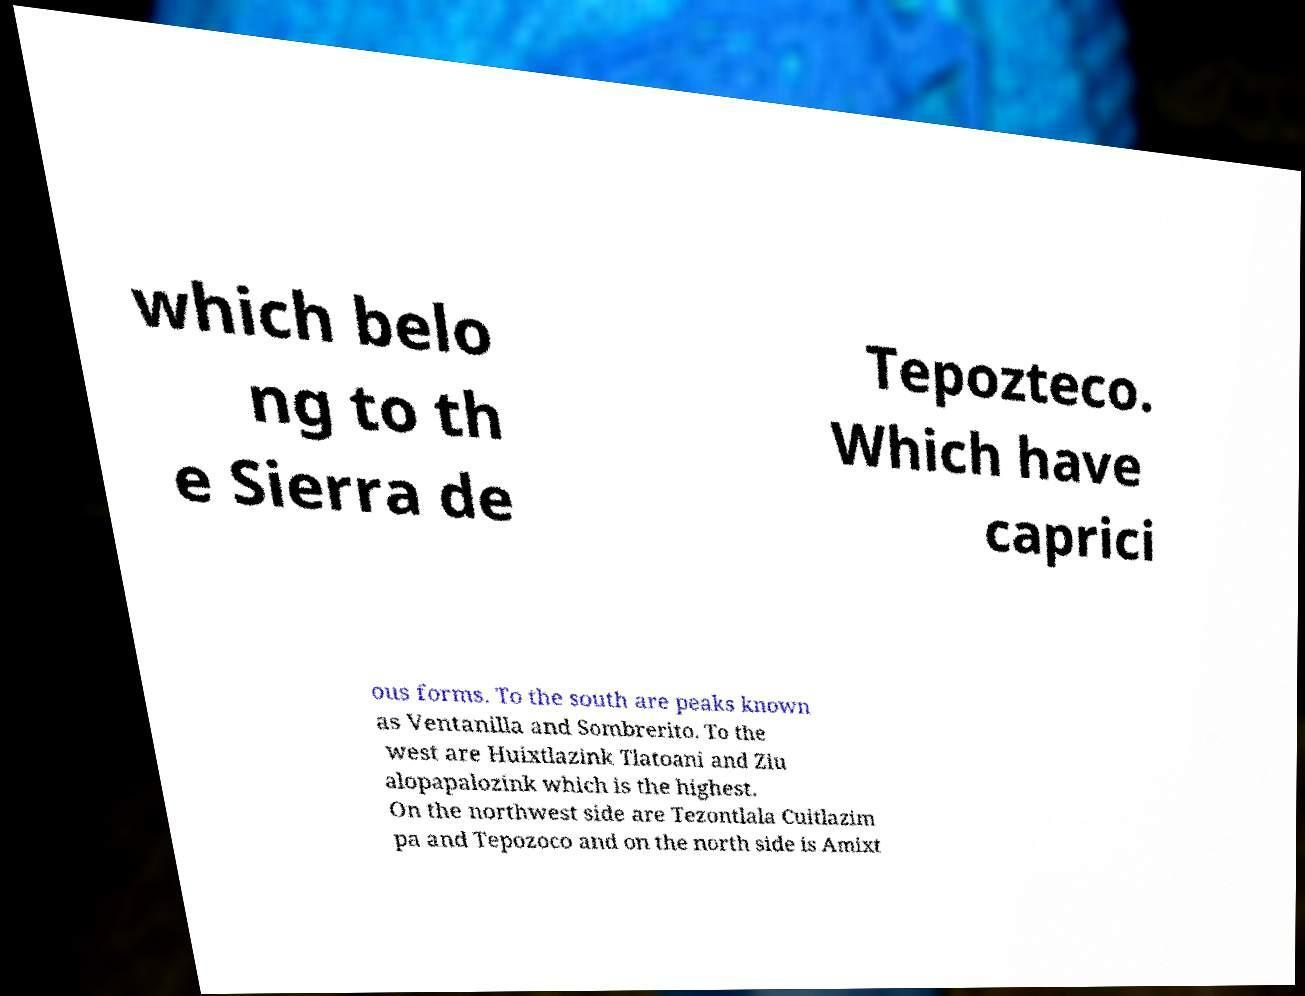Please identify and transcribe the text found in this image. which belo ng to th e Sierra de Tepozteco. Which have caprici ous forms. To the south are peaks known as Ventanilla and Sombrerito. To the west are Huixtlazink Tlatoani and Ziu alopapalozink which is the highest. On the northwest side are Tezontlala Cuitlazim pa and Tepozoco and on the north side is Amixt 